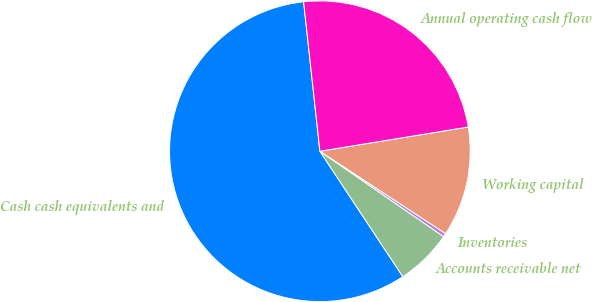Convert chart to OTSL. <chart><loc_0><loc_0><loc_500><loc_500><pie_chart><fcel>Cash cash equivalents and<fcel>Accounts receivable net<fcel>Inventories<fcel>Working capital<fcel>Annual operating cash flow<nl><fcel>57.57%<fcel>6.09%<fcel>0.38%<fcel>11.81%<fcel>24.15%<nl></chart> 